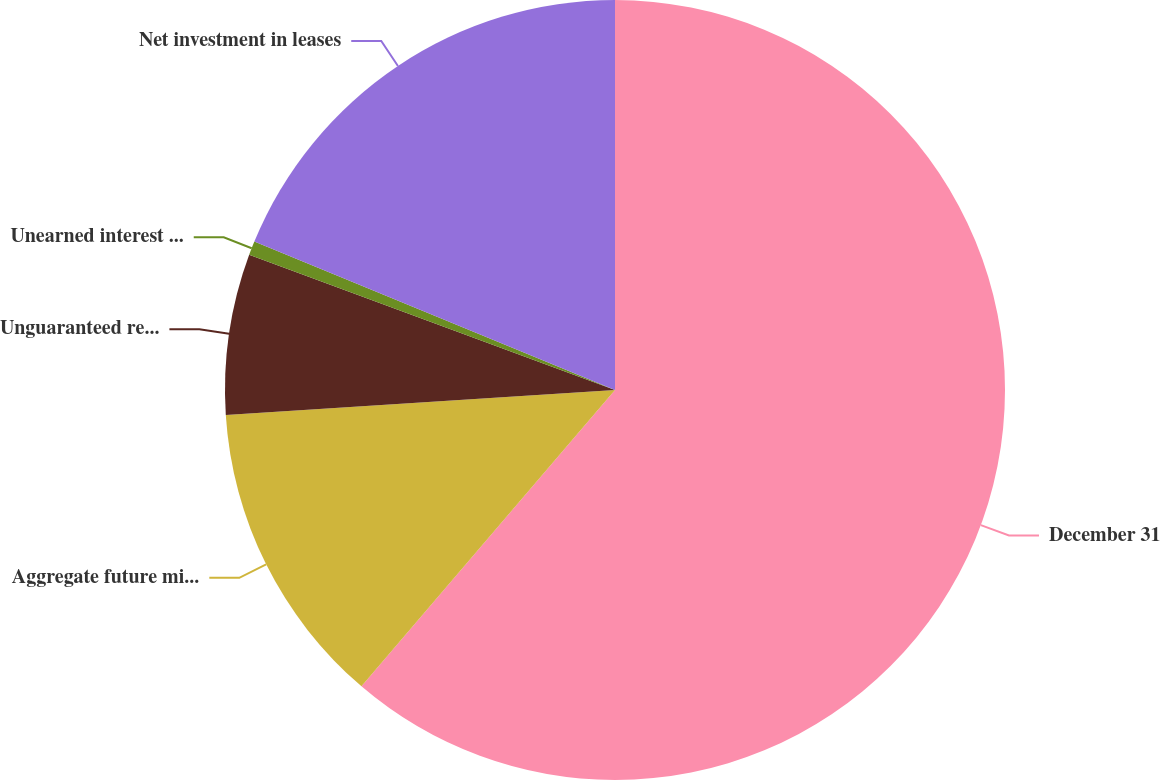Convert chart to OTSL. <chart><loc_0><loc_0><loc_500><loc_500><pie_chart><fcel>December 31<fcel>Aggregate future minimum lease<fcel>Unguaranteed residual value<fcel>Unearned interest income<fcel>Net investment in leases<nl><fcel>61.27%<fcel>12.72%<fcel>6.65%<fcel>0.58%<fcel>18.79%<nl></chart> 